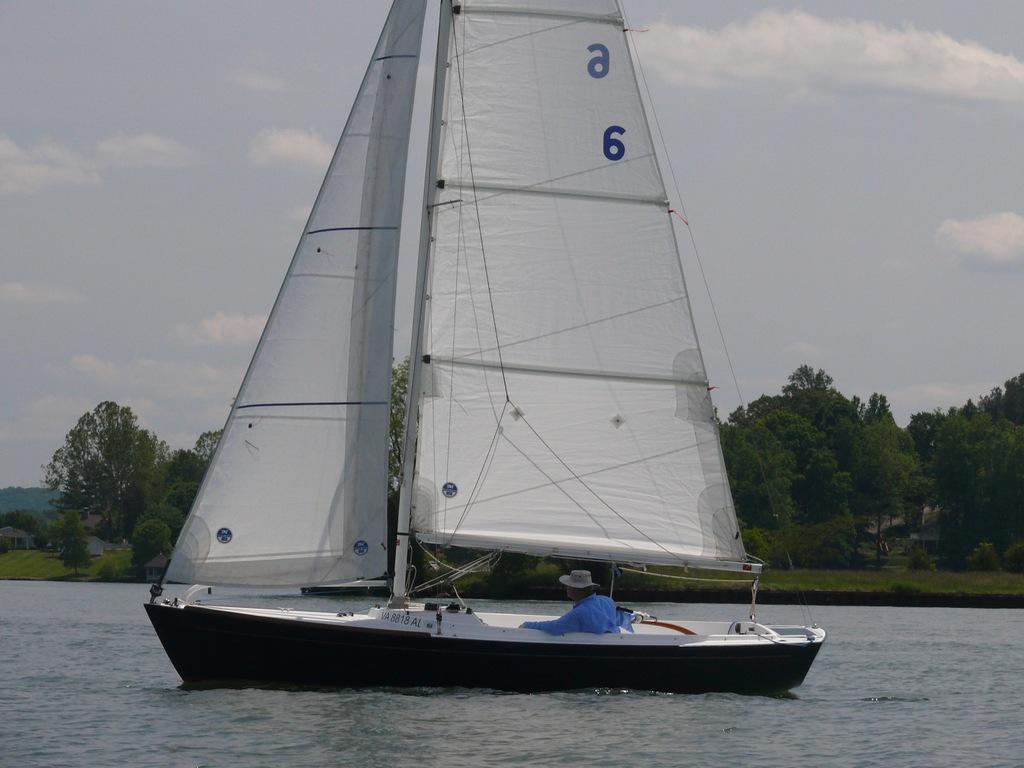<image>
Write a terse but informative summary of the picture. A small sailboat that says a6 on the sails has a man in a blue shirt steering it. 